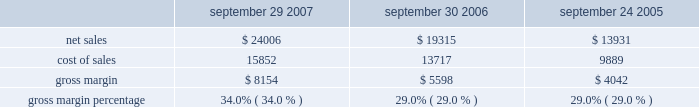Capital asset purchases associated with the retail segment were $ 294 million in 2007 , bringing the total capital asset purchases since inception of the retail segment to $ 1.0 billion .
As of september 29 , 2007 , the retail segment had approximately 7900 employees and had outstanding operating lease commitments associated with retail store space and related facilities of $ 1.1 billion .
The company would incur substantial costs if it were to close multiple retail stores .
Such costs could adversely affect the company 2019s financial condition and operating results .
Other segments the company 2019s other segments , which consists of its asia pacific and filemaker operations , experienced an increase in net sales of $ 406 million , or 30% ( 30 % ) during 2007 compared to 2006 .
This increase related primarily to a 58% ( 58 % ) increase in sales of mac portable products and strong ipod sales in the company 2019s asia pacific region .
During 2006 , net sales in other segments increased 35% ( 35 % ) compared to 2005 primarily due to an increase in sales of ipod and mac portable products .
Strong sales growth was a result of the introduction of the updated ipods featuring video-playing capabilities and the new intel-based mac portable products that translated to a 16% ( 16 % ) increase in mac unit sales during 2006 compared to 2005 .
Gross margin gross margin for each of the last three fiscal years are as follows ( in millions , except gross margin percentages ) : september 29 , september 30 , september 24 , 2007 2006 2005 .
Gross margin percentage of 34.0% ( 34.0 % ) in 2007 increased significantly from 29.0% ( 29.0 % ) in 2006 .
The primary drivers of this increase were more favorable costs on certain commodity components , including nand flash memory and dram memory , higher overall revenue that provided for more leverage on fixed production costs and a higher percentage of revenue from the company 2019s direct sales channels .
The company anticipates that its gross margin and the gross margins of the personal computer , consumer electronics and mobile communication industries will be subject to pressure due to price competition .
The company expects gross margin percentage to decline sequentially in the first quarter of 2008 primarily as a result of the full-quarter impact of product transitions and reduced pricing that were effected in the fourth quarter of 2007 , lower sales of ilife and iwork in their second quarter of availability , seasonally higher component costs , and a higher mix of indirect sales .
These factors are expected to be partially offset by higher sales of the company 2019s mac os x operating system due to the introduction of mac os x version 10.5 leopard ( 2018 2018mac os x leopard 2019 2019 ) that became available in october 2007 .
The foregoing statements regarding the company 2019s expected gross margin percentage are forward-looking .
There can be no assurance that current gross margin percentage will be maintained or targeted gross margin percentage levels will be achieved .
In general , gross margins and margins on individual products will remain under downward pressure due to a variety of factors , including continued industry wide global pricing pressures , increased competition , compressed product life cycles , potential increases in the cost and availability of raw material and outside manufacturing services , and a potential shift in the company 2019s sales mix towards products with lower gross margins .
In response to these competitive pressures , the company expects it will continue to take pricing actions with respect to its products .
Gross margins could also be affected by the company 2019s ability to effectively manage product quality and warranty costs and to stimulate .
What was the change in cost of sales between 2007 and 2008 , in millions?15852 13717? 
Computations: (15852 - 13717)
Answer: 2135.0. Capital asset purchases associated with the retail segment were $ 294 million in 2007 , bringing the total capital asset purchases since inception of the retail segment to $ 1.0 billion .
As of september 29 , 2007 , the retail segment had approximately 7900 employees and had outstanding operating lease commitments associated with retail store space and related facilities of $ 1.1 billion .
The company would incur substantial costs if it were to close multiple retail stores .
Such costs could adversely affect the company 2019s financial condition and operating results .
Other segments the company 2019s other segments , which consists of its asia pacific and filemaker operations , experienced an increase in net sales of $ 406 million , or 30% ( 30 % ) during 2007 compared to 2006 .
This increase related primarily to a 58% ( 58 % ) increase in sales of mac portable products and strong ipod sales in the company 2019s asia pacific region .
During 2006 , net sales in other segments increased 35% ( 35 % ) compared to 2005 primarily due to an increase in sales of ipod and mac portable products .
Strong sales growth was a result of the introduction of the updated ipods featuring video-playing capabilities and the new intel-based mac portable products that translated to a 16% ( 16 % ) increase in mac unit sales during 2006 compared to 2005 .
Gross margin gross margin for each of the last three fiscal years are as follows ( in millions , except gross margin percentages ) : september 29 , september 30 , september 24 , 2007 2006 2005 .
Gross margin percentage of 34.0% ( 34.0 % ) in 2007 increased significantly from 29.0% ( 29.0 % ) in 2006 .
The primary drivers of this increase were more favorable costs on certain commodity components , including nand flash memory and dram memory , higher overall revenue that provided for more leverage on fixed production costs and a higher percentage of revenue from the company 2019s direct sales channels .
The company anticipates that its gross margin and the gross margins of the personal computer , consumer electronics and mobile communication industries will be subject to pressure due to price competition .
The company expects gross margin percentage to decline sequentially in the first quarter of 2008 primarily as a result of the full-quarter impact of product transitions and reduced pricing that were effected in the fourth quarter of 2007 , lower sales of ilife and iwork in their second quarter of availability , seasonally higher component costs , and a higher mix of indirect sales .
These factors are expected to be partially offset by higher sales of the company 2019s mac os x operating system due to the introduction of mac os x version 10.5 leopard ( 2018 2018mac os x leopard 2019 2019 ) that became available in october 2007 .
The foregoing statements regarding the company 2019s expected gross margin percentage are forward-looking .
There can be no assurance that current gross margin percentage will be maintained or targeted gross margin percentage levels will be achieved .
In general , gross margins and margins on individual products will remain under downward pressure due to a variety of factors , including continued industry wide global pricing pressures , increased competition , compressed product life cycles , potential increases in the cost and availability of raw material and outside manufacturing services , and a potential shift in the company 2019s sales mix towards products with lower gross margins .
In response to these competitive pressures , the company expects it will continue to take pricing actions with respect to its products .
Gross margins could also be affected by the company 2019s ability to effectively manage product quality and warranty costs and to stimulate .
What was the percentage sales change from 2005 to 2006? 
Computations: ((19315 - 13931) / 13931)
Answer: 0.38648. 